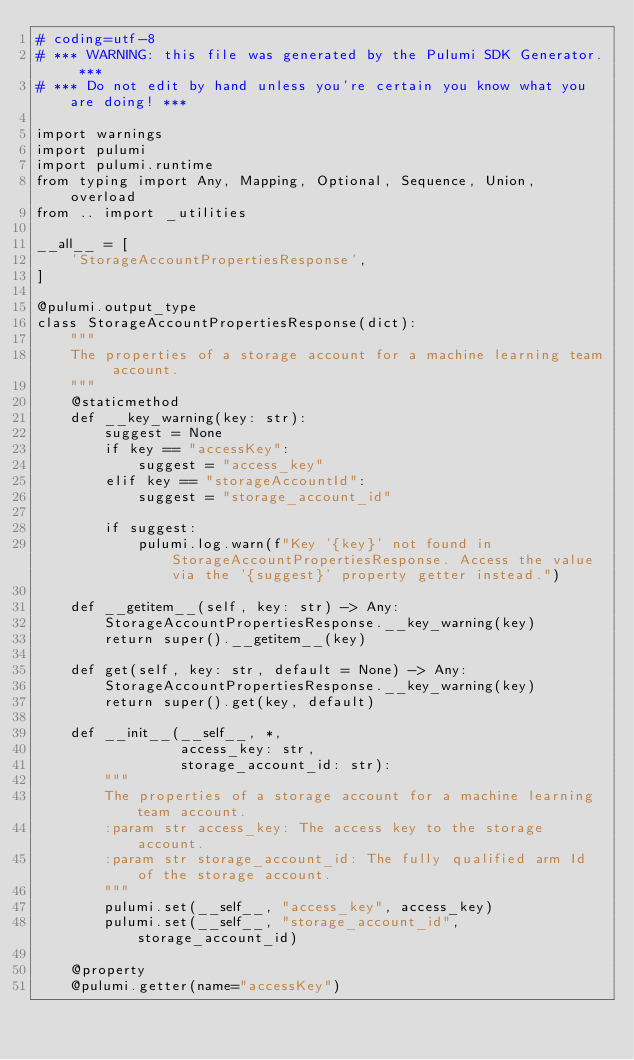<code> <loc_0><loc_0><loc_500><loc_500><_Python_># coding=utf-8
# *** WARNING: this file was generated by the Pulumi SDK Generator. ***
# *** Do not edit by hand unless you're certain you know what you are doing! ***

import warnings
import pulumi
import pulumi.runtime
from typing import Any, Mapping, Optional, Sequence, Union, overload
from .. import _utilities

__all__ = [
    'StorageAccountPropertiesResponse',
]

@pulumi.output_type
class StorageAccountPropertiesResponse(dict):
    """
    The properties of a storage account for a machine learning team account.
    """
    @staticmethod
    def __key_warning(key: str):
        suggest = None
        if key == "accessKey":
            suggest = "access_key"
        elif key == "storageAccountId":
            suggest = "storage_account_id"

        if suggest:
            pulumi.log.warn(f"Key '{key}' not found in StorageAccountPropertiesResponse. Access the value via the '{suggest}' property getter instead.")

    def __getitem__(self, key: str) -> Any:
        StorageAccountPropertiesResponse.__key_warning(key)
        return super().__getitem__(key)

    def get(self, key: str, default = None) -> Any:
        StorageAccountPropertiesResponse.__key_warning(key)
        return super().get(key, default)

    def __init__(__self__, *,
                 access_key: str,
                 storage_account_id: str):
        """
        The properties of a storage account for a machine learning team account.
        :param str access_key: The access key to the storage account.
        :param str storage_account_id: The fully qualified arm Id of the storage account.
        """
        pulumi.set(__self__, "access_key", access_key)
        pulumi.set(__self__, "storage_account_id", storage_account_id)

    @property
    @pulumi.getter(name="accessKey")</code> 